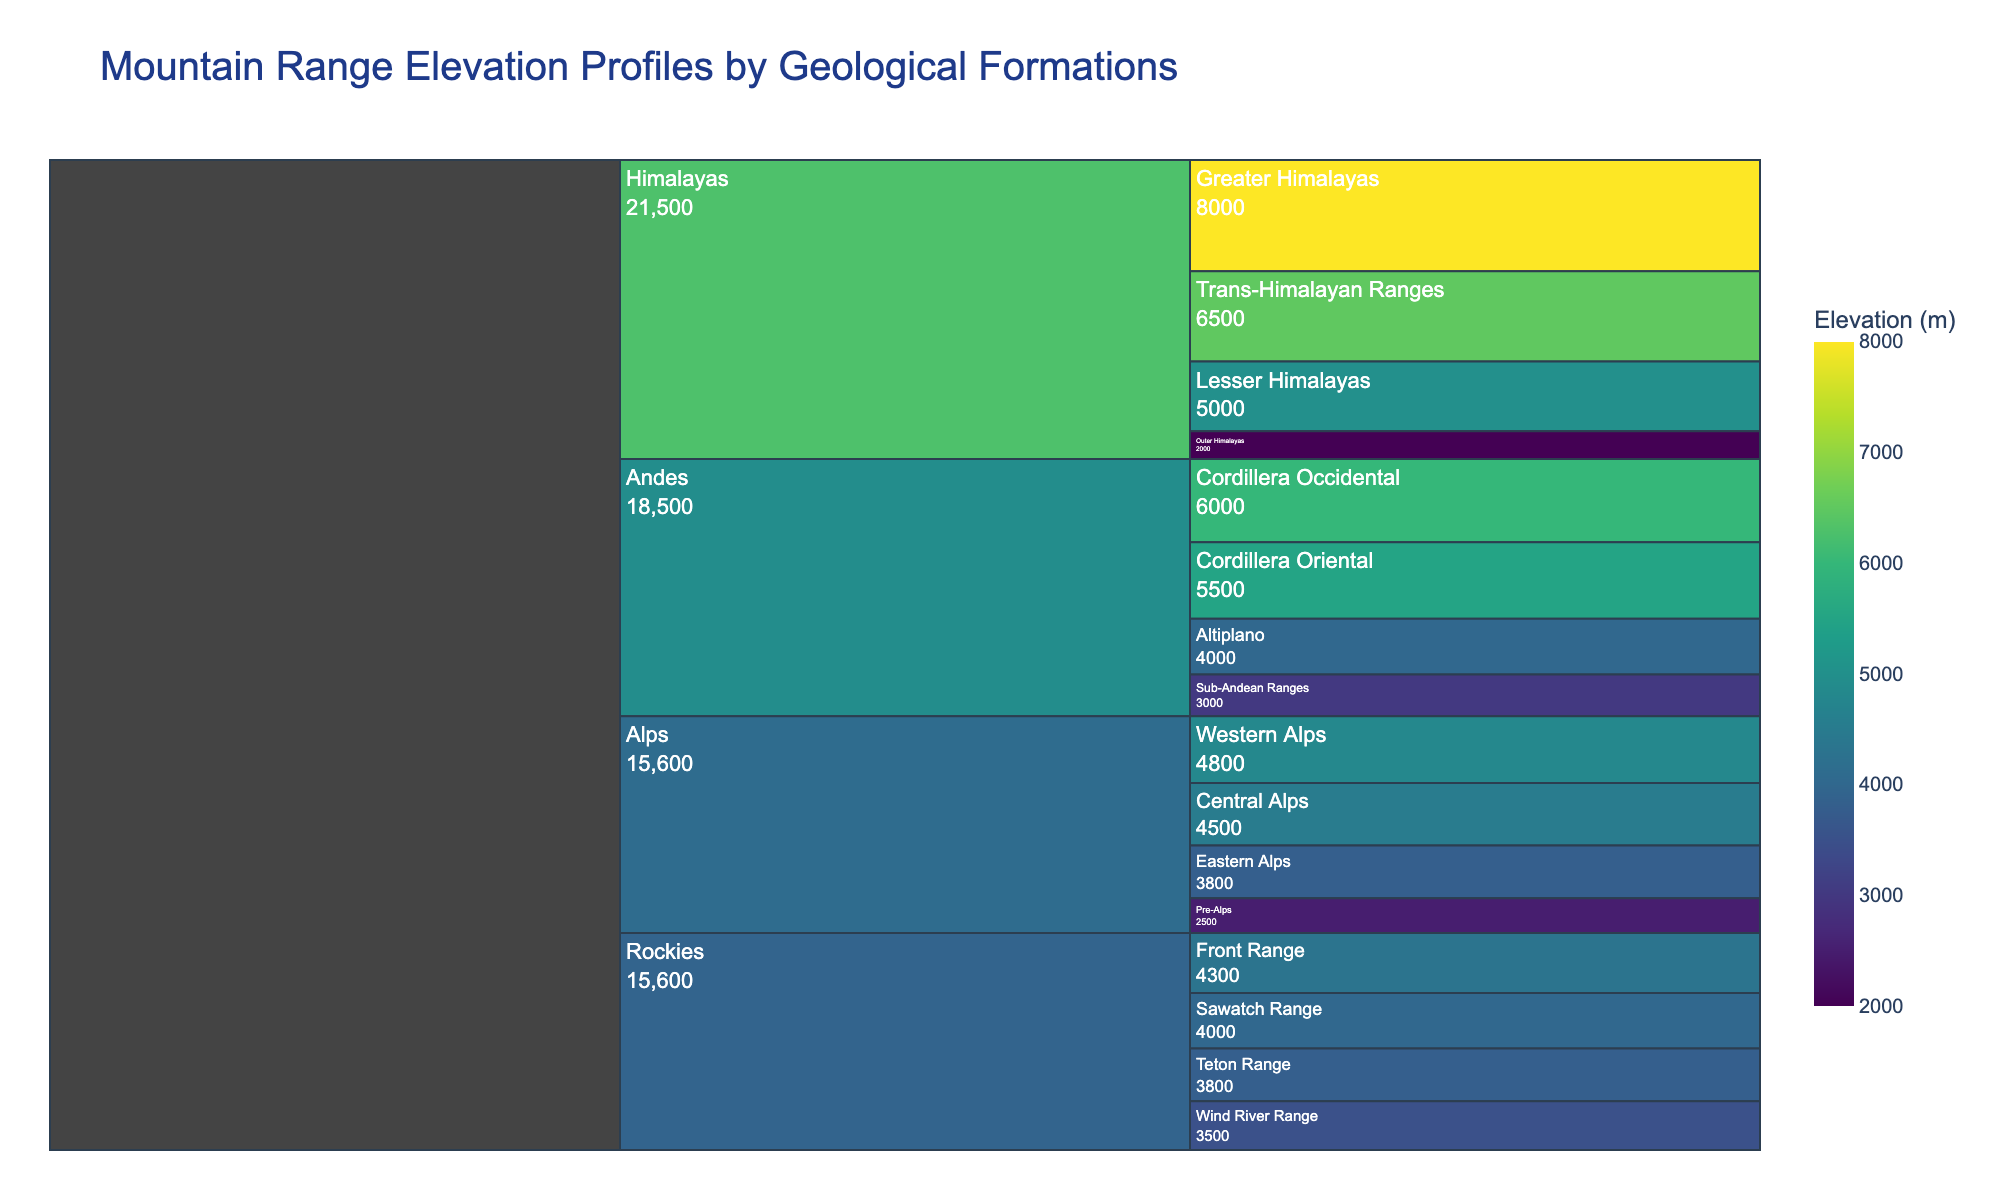What is the title of the Icicle chart? The title of the Icicle chart is usually located at the top of the chart in a larger font. It represents the main topic or subject of the visualization.
Answer: Mountain Range Elevation Profiles by Geological Formations Which geological formation in the Rockies has the highest elevation? Look for the section under the Rockies node and identify the geological formation with the highest number.
Answer: Front Range What is the difference in elevation between the Greater Himalayas and the Altiplano? Locate the Greater Himalayas and the Altiplano in the Icicle chart and subtract the elevation value of the Altiplano from that of the Greater Himalayas: 8000 m - 4000 m.
Answer: 4000 m Which mountain range has the lowest minimum elevation among its geological formations? Identify the lowest value within each mountain range section, then compare these minimum values across different mountain ranges. The mountain range with the smallest value is the answer.
Answer: Himalayas How many geological formations in the Alps have elevations above 3000 meters? Look at the sub-sections under the Alps node and count the geological formations that have elevation values greater than 3000 meters.
Answer: 3 What is the elevation range within the Andes? Identify the maximum and minimum elevation values in the Andes section: 6000 m (Cordillera Occidental) - 3000 m (Sub-Andean Ranges). Calculate the range by subtracting the smallest value from the largest value.
Answer: 3000 m Which geological formation overall has the highest elevation? Scan through all the geological formations across all mountain ranges and identify the one with the highest elevation value.
Answer: Greater Himalayas Which mountain range has the widest spread of geological formations based on the variety of colors in the chart? Observe the number of different colors within each main mountain range section in the icicle chart. The range with the most diverse set of colors has the widest spread.
Answer: Andes What is the average elevation of the geological formations in the Rockies? Sum up the elevation values of all geological formations in the Rockies and divide by the number of formations: (4300 + 4000 + 3800 + 3500) / 4.
Answer: 3900 m What proportion of geological formations in the Himalayas have an elevation above 5000 meters? Count the number of geological formations in the Himalayas, then count how many of these have elevations above 5000 meters. Divide the count of formations above 5000 meters by the total count and multiply by 100 to get the percentage.
Answer: 50% 